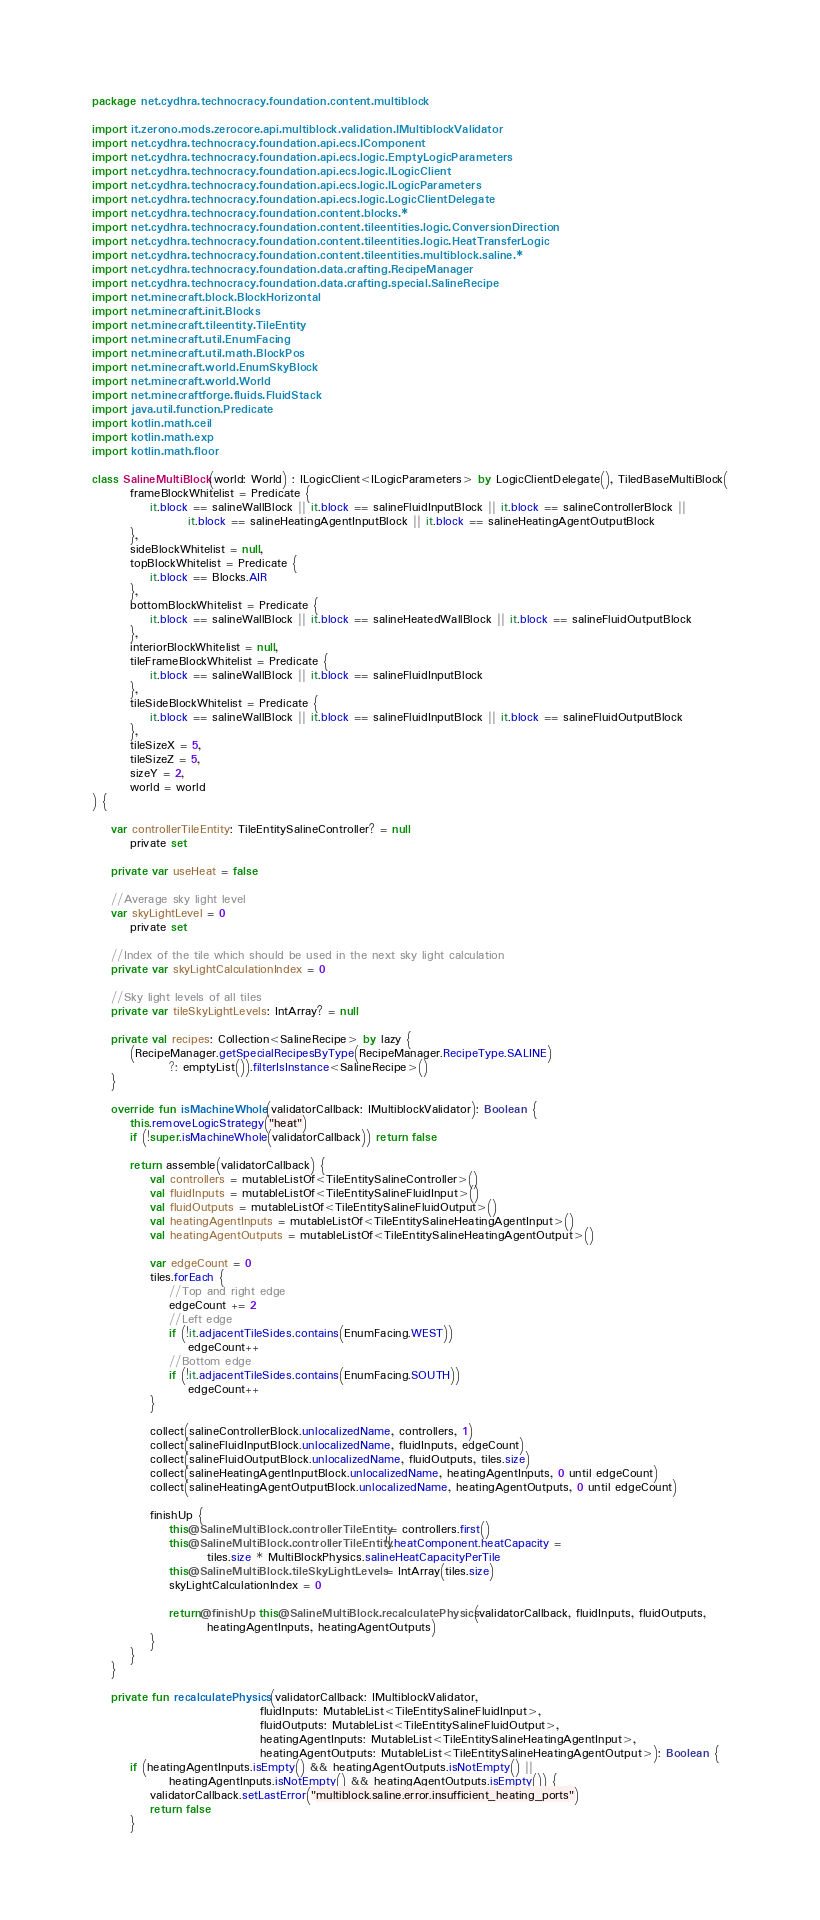<code> <loc_0><loc_0><loc_500><loc_500><_Kotlin_>package net.cydhra.technocracy.foundation.content.multiblock

import it.zerono.mods.zerocore.api.multiblock.validation.IMultiblockValidator
import net.cydhra.technocracy.foundation.api.ecs.IComponent
import net.cydhra.technocracy.foundation.api.ecs.logic.EmptyLogicParameters
import net.cydhra.technocracy.foundation.api.ecs.logic.ILogicClient
import net.cydhra.technocracy.foundation.api.ecs.logic.ILogicParameters
import net.cydhra.technocracy.foundation.api.ecs.logic.LogicClientDelegate
import net.cydhra.technocracy.foundation.content.blocks.*
import net.cydhra.technocracy.foundation.content.tileentities.logic.ConversionDirection
import net.cydhra.technocracy.foundation.content.tileentities.logic.HeatTransferLogic
import net.cydhra.technocracy.foundation.content.tileentities.multiblock.saline.*
import net.cydhra.technocracy.foundation.data.crafting.RecipeManager
import net.cydhra.technocracy.foundation.data.crafting.special.SalineRecipe
import net.minecraft.block.BlockHorizontal
import net.minecraft.init.Blocks
import net.minecraft.tileentity.TileEntity
import net.minecraft.util.EnumFacing
import net.minecraft.util.math.BlockPos
import net.minecraft.world.EnumSkyBlock
import net.minecraft.world.World
import net.minecraftforge.fluids.FluidStack
import java.util.function.Predicate
import kotlin.math.ceil
import kotlin.math.exp
import kotlin.math.floor

class SalineMultiBlock(world: World) : ILogicClient<ILogicParameters> by LogicClientDelegate(), TiledBaseMultiBlock(
        frameBlockWhitelist = Predicate {
            it.block == salineWallBlock || it.block == salineFluidInputBlock || it.block == salineControllerBlock ||
                    it.block == salineHeatingAgentInputBlock || it.block == salineHeatingAgentOutputBlock
        },
        sideBlockWhitelist = null,
        topBlockWhitelist = Predicate {
            it.block == Blocks.AIR
        },
        bottomBlockWhitelist = Predicate {
            it.block == salineWallBlock || it.block == salineHeatedWallBlock || it.block == salineFluidOutputBlock
        },
        interiorBlockWhitelist = null,
        tileFrameBlockWhitelist = Predicate {
            it.block == salineWallBlock || it.block == salineFluidInputBlock
        },
        tileSideBlockWhitelist = Predicate {
            it.block == salineWallBlock || it.block == salineFluidInputBlock || it.block == salineFluidOutputBlock
        },
        tileSizeX = 5,
        tileSizeZ = 5,
        sizeY = 2,
        world = world
) {

    var controllerTileEntity: TileEntitySalineController? = null
        private set

    private var useHeat = false

    //Average sky light level
    var skyLightLevel = 0
        private set

    //Index of the tile which should be used in the next sky light calculation
    private var skyLightCalculationIndex = 0

    //Sky light levels of all tiles
    private var tileSkyLightLevels: IntArray? = null

    private val recipes: Collection<SalineRecipe> by lazy {
        (RecipeManager.getSpecialRecipesByType(RecipeManager.RecipeType.SALINE)
                ?: emptyList()).filterIsInstance<SalineRecipe>()
    }

    override fun isMachineWhole(validatorCallback: IMultiblockValidator): Boolean {
        this.removeLogicStrategy("heat")
        if (!super.isMachineWhole(validatorCallback)) return false

        return assemble(validatorCallback) {
            val controllers = mutableListOf<TileEntitySalineController>()
            val fluidInputs = mutableListOf<TileEntitySalineFluidInput>()
            val fluidOutputs = mutableListOf<TileEntitySalineFluidOutput>()
            val heatingAgentInputs = mutableListOf<TileEntitySalineHeatingAgentInput>()
            val heatingAgentOutputs = mutableListOf<TileEntitySalineHeatingAgentOutput>()

            var edgeCount = 0
            tiles.forEach {
                //Top and right edge
                edgeCount += 2
                //Left edge
                if (!it.adjacentTileSides.contains(EnumFacing.WEST))
                    edgeCount++
                //Bottom edge
                if (!it.adjacentTileSides.contains(EnumFacing.SOUTH))
                    edgeCount++
            }

            collect(salineControllerBlock.unlocalizedName, controllers, 1)
            collect(salineFluidInputBlock.unlocalizedName, fluidInputs, edgeCount)
            collect(salineFluidOutputBlock.unlocalizedName, fluidOutputs, tiles.size)
            collect(salineHeatingAgentInputBlock.unlocalizedName, heatingAgentInputs, 0 until edgeCount)
            collect(salineHeatingAgentOutputBlock.unlocalizedName, heatingAgentOutputs, 0 until edgeCount)

            finishUp {
                this@SalineMultiBlock.controllerTileEntity = controllers.first()
                this@SalineMultiBlock.controllerTileEntity!!.heatComponent.heatCapacity =
                        tiles.size * MultiBlockPhysics.salineHeatCapacityPerTile
                this@SalineMultiBlock.tileSkyLightLevels = IntArray(tiles.size)
                skyLightCalculationIndex = 0

                return@finishUp this@SalineMultiBlock.recalculatePhysics(validatorCallback, fluidInputs, fluidOutputs,
                        heatingAgentInputs, heatingAgentOutputs)
            }
        }
    }

    private fun recalculatePhysics(validatorCallback: IMultiblockValidator,
                                   fluidInputs: MutableList<TileEntitySalineFluidInput>,
                                   fluidOutputs: MutableList<TileEntitySalineFluidOutput>,
                                   heatingAgentInputs: MutableList<TileEntitySalineHeatingAgentInput>,
                                   heatingAgentOutputs: MutableList<TileEntitySalineHeatingAgentOutput>): Boolean {
        if (heatingAgentInputs.isEmpty() && heatingAgentOutputs.isNotEmpty() ||
                heatingAgentInputs.isNotEmpty() && heatingAgentOutputs.isEmpty()) {
            validatorCallback.setLastError("multiblock.saline.error.insufficient_heating_ports")
            return false
        }
</code> 